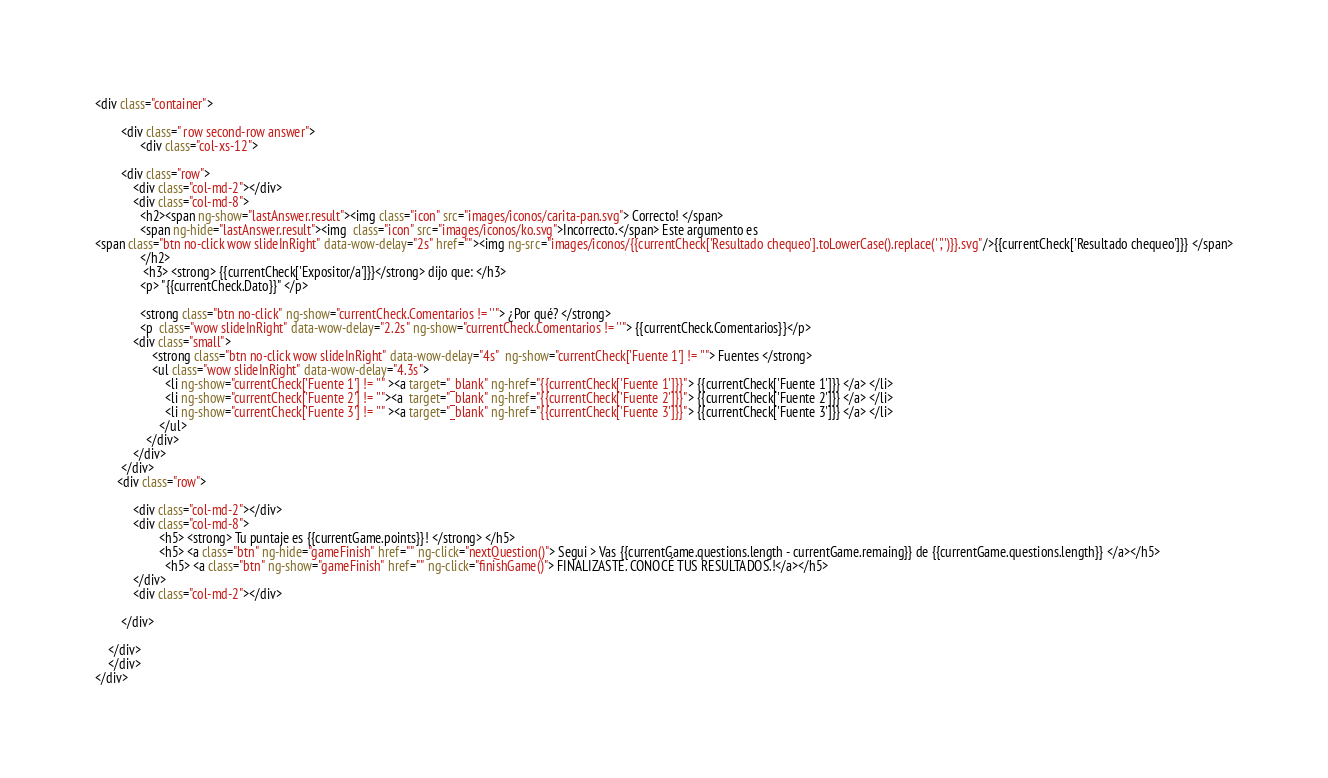Convert code to text. <code><loc_0><loc_0><loc_500><loc_500><_HTML_><div class="container">
           
        <div class=" row second-row answer">
              <div class="col-xs-12">
        
        <div class="row">
            <div class="col-md-2"></div>
            <div class="col-md-8">
              <h2><span ng-show="lastAnswer.result"><img class="icon" src="images/iconos/carita-pan.svg"> Correcto! </span>
              <span ng-hide="lastAnswer.result"><img  class="icon" src="images/iconos/ko.svg">Incorrecto.</span> Este argumento es 
<span class="btn no-click wow slideInRight" data-wow-delay="2s" href=""><img ng-src="images/iconos/{{currentCheck['Resultado chequeo'].toLowerCase().replace(' ','')}}.svg"/>{{currentCheck['Resultado chequeo']}} </span>
              </h2>
               <h3> <strong> {{currentCheck['Expositor/a']}}</strong> dijo que: </h3>
              <p> "{{currentCheck.Dato}}" </p>
             
              <strong class="btn no-click" ng-show="currentCheck.Comentarios != ''"> ¿Por qué? </strong>
              <p  class="wow slideInRight" data-wow-delay="2.2s" ng-show="currentCheck.Comentarios != ''"> {{currentCheck.Comentarios}}</p>
            <div class="small">
                  <strong class="btn no-click wow slideInRight" data-wow-delay="4s"  ng-show="currentCheck['Fuente 1'] != ''"> Fuentes </strong>
                  <ul class="wow slideInRight" data-wow-delay="4.3s">
                      <li ng-show="currentCheck['Fuente 1'] != ''" ><a target="_blank" ng-href="{{currentCheck['Fuente 1']}}"> {{currentCheck['Fuente 1']}} </a> </li>
                      <li ng-show="currentCheck['Fuente 2'] != ''"><a  target="_blank" ng-href="{{currentCheck['Fuente 2']}}"> {{currentCheck['Fuente 2']}} </a> </li>
                      <li ng-show="currentCheck['Fuente 3'] != ''" ><a target="_blank" ng-href="{{currentCheck['Fuente 3']}}"> {{currentCheck['Fuente 3']}} </a> </li>
                    </ul>
                </div>
            </div>
        </div>
       <div class="row">

            <div class="col-md-2"></div>
            <div class="col-md-8">
                    <h5> <strong> Tu puntaje es {{currentGame.points}}! </strong> </h5>
                    <h5> <a class="btn" ng-hide="gameFinish" href="" ng-click="nextQuestion()"> Segui > Vas {{currentGame.questions.length - currentGame.remaing}} de {{currentGame.questions.length}} </a></h5>
                      <h5> <a class="btn" ng-show="gameFinish" href="" ng-click="finishGame()"> FINALIZASTE. CONOCÉ TUS RESULTADOS.!</a></h5>
            </div>
            <div class="col-md-2"></div>
            
        </div>
          
    </div>
    </div>          
</div>


</code> 